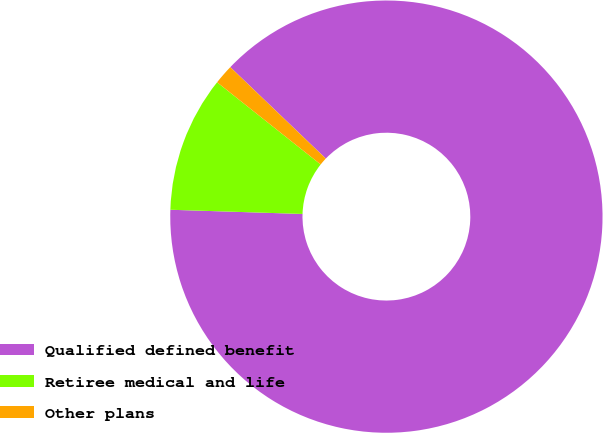Convert chart to OTSL. <chart><loc_0><loc_0><loc_500><loc_500><pie_chart><fcel>Qualified defined benefit<fcel>Retiree medical and life<fcel>Other plans<nl><fcel>88.36%<fcel>10.17%<fcel>1.48%<nl></chart> 